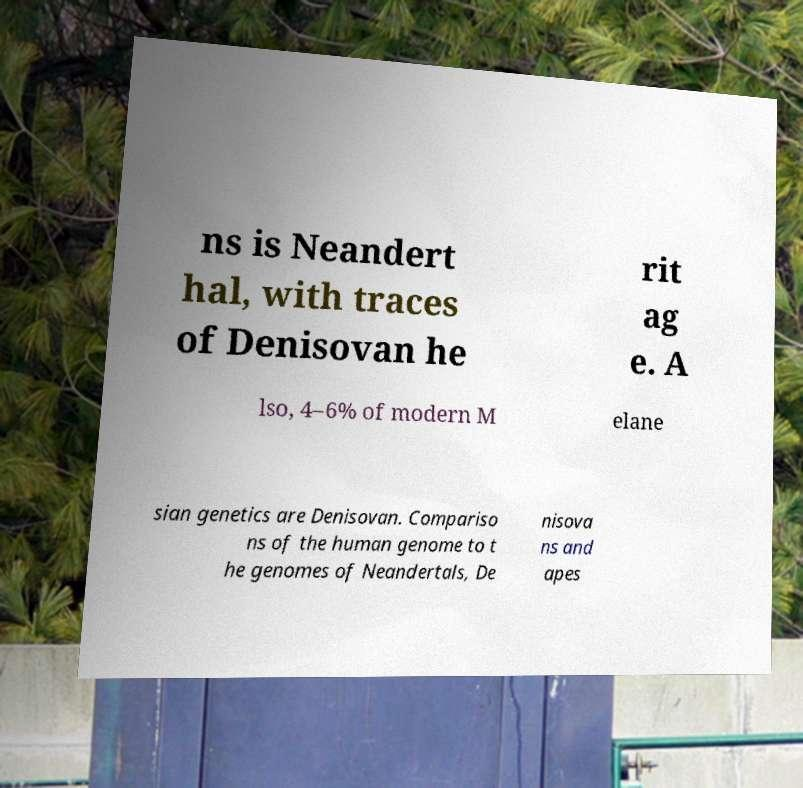I need the written content from this picture converted into text. Can you do that? ns is Neandert hal, with traces of Denisovan he rit ag e. A lso, 4–6% of modern M elane sian genetics are Denisovan. Compariso ns of the human genome to t he genomes of Neandertals, De nisova ns and apes 